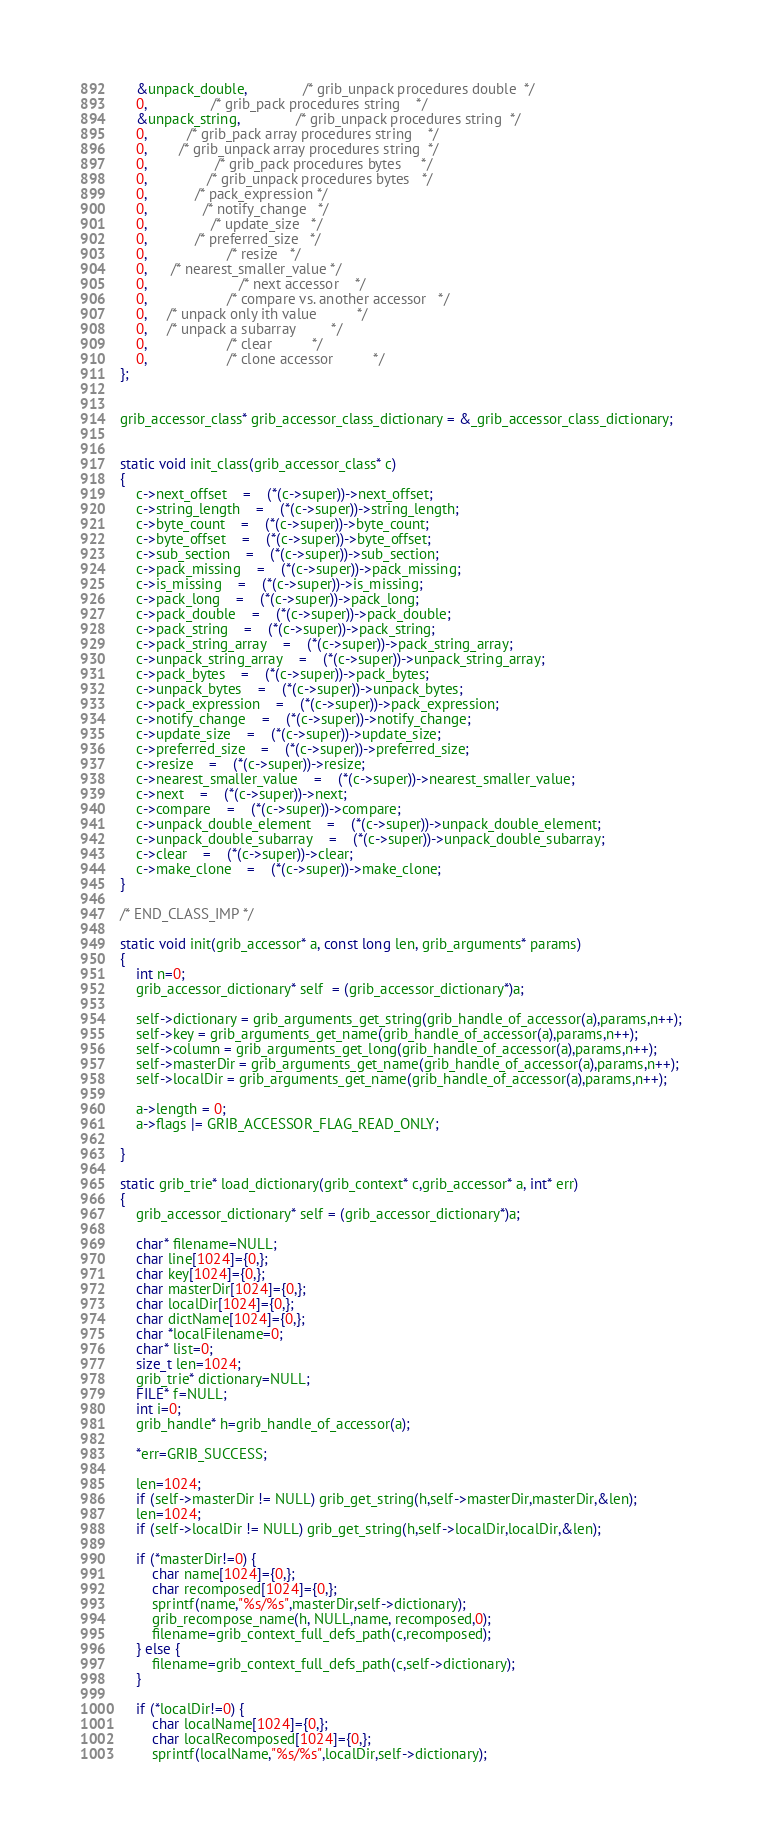<code> <loc_0><loc_0><loc_500><loc_500><_C_>    &unpack_double,              /* grib_unpack procedures double  */
    0,                /* grib_pack procedures string    */
    &unpack_string,              /* grib_unpack procedures string  */
    0,          /* grib_pack array procedures string    */
    0,        /* grib_unpack array procedures string  */
    0,                 /* grib_pack procedures bytes     */
    0,               /* grib_unpack procedures bytes   */
    0,            /* pack_expression */
    0,              /* notify_change   */
    0,                /* update_size   */
    0,            /* preferred_size   */
    0,                    /* resize   */
    0,      /* nearest_smaller_value */
    0,                       /* next accessor    */
    0,                    /* compare vs. another accessor   */
    0,     /* unpack only ith value          */
    0,     /* unpack a subarray         */
    0,              		/* clear          */
    0,               		/* clone accessor          */
};


grib_accessor_class* grib_accessor_class_dictionary = &_grib_accessor_class_dictionary;


static void init_class(grib_accessor_class* c)
{
	c->next_offset	=	(*(c->super))->next_offset;
	c->string_length	=	(*(c->super))->string_length;
	c->byte_count	=	(*(c->super))->byte_count;
	c->byte_offset	=	(*(c->super))->byte_offset;
	c->sub_section	=	(*(c->super))->sub_section;
	c->pack_missing	=	(*(c->super))->pack_missing;
	c->is_missing	=	(*(c->super))->is_missing;
	c->pack_long	=	(*(c->super))->pack_long;
	c->pack_double	=	(*(c->super))->pack_double;
	c->pack_string	=	(*(c->super))->pack_string;
	c->pack_string_array	=	(*(c->super))->pack_string_array;
	c->unpack_string_array	=	(*(c->super))->unpack_string_array;
	c->pack_bytes	=	(*(c->super))->pack_bytes;
	c->unpack_bytes	=	(*(c->super))->unpack_bytes;
	c->pack_expression	=	(*(c->super))->pack_expression;
	c->notify_change	=	(*(c->super))->notify_change;
	c->update_size	=	(*(c->super))->update_size;
	c->preferred_size	=	(*(c->super))->preferred_size;
	c->resize	=	(*(c->super))->resize;
	c->nearest_smaller_value	=	(*(c->super))->nearest_smaller_value;
	c->next	=	(*(c->super))->next;
	c->compare	=	(*(c->super))->compare;
	c->unpack_double_element	=	(*(c->super))->unpack_double_element;
	c->unpack_double_subarray	=	(*(c->super))->unpack_double_subarray;
	c->clear	=	(*(c->super))->clear;
	c->make_clone	=	(*(c->super))->make_clone;
}

/* END_CLASS_IMP */

static void init(grib_accessor* a, const long len, grib_arguments* params)
{
    int n=0;
    grib_accessor_dictionary* self  = (grib_accessor_dictionary*)a;

    self->dictionary = grib_arguments_get_string(grib_handle_of_accessor(a),params,n++);
    self->key = grib_arguments_get_name(grib_handle_of_accessor(a),params,n++);
    self->column = grib_arguments_get_long(grib_handle_of_accessor(a),params,n++);
    self->masterDir = grib_arguments_get_name(grib_handle_of_accessor(a),params,n++);
    self->localDir = grib_arguments_get_name(grib_handle_of_accessor(a),params,n++);

    a->length = 0;
    a->flags |= GRIB_ACCESSOR_FLAG_READ_ONLY;

}

static grib_trie* load_dictionary(grib_context* c,grib_accessor* a, int* err)
{
    grib_accessor_dictionary* self = (grib_accessor_dictionary*)a;

    char* filename=NULL;
    char line[1024]={0,};
    char key[1024]={0,};
    char masterDir[1024]={0,};
    char localDir[1024]={0,};
    char dictName[1024]={0,};
    char *localFilename=0;
    char* list=0;
    size_t len=1024;
    grib_trie* dictionary=NULL;
    FILE* f=NULL;
    int i=0;
    grib_handle* h=grib_handle_of_accessor(a);

    *err=GRIB_SUCCESS;

    len=1024;
    if (self->masterDir != NULL) grib_get_string(h,self->masterDir,masterDir,&len);
    len=1024;
    if (self->localDir != NULL) grib_get_string(h,self->localDir,localDir,&len);

    if (*masterDir!=0) {
        char name[1024]={0,};
        char recomposed[1024]={0,};
        sprintf(name,"%s/%s",masterDir,self->dictionary);
        grib_recompose_name(h, NULL,name, recomposed,0);
        filename=grib_context_full_defs_path(c,recomposed);
    } else {
        filename=grib_context_full_defs_path(c,self->dictionary);
    }

    if (*localDir!=0) {
        char localName[1024]={0,};
        char localRecomposed[1024]={0,};
        sprintf(localName,"%s/%s",localDir,self->dictionary);</code> 